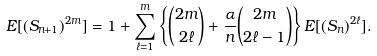Convert formula to latex. <formula><loc_0><loc_0><loc_500><loc_500>E [ ( S _ { n + 1 } ) ^ { 2 m } ] & = 1 + \sum _ { \ell = 1 } ^ { m } \left \{ \binom { 2 m } { 2 \ell } + \frac { \alpha } { n } \binom { 2 m } { 2 \ell - 1 } \right \} E [ ( S _ { n } ) ^ { 2 \ell } ] .</formula> 